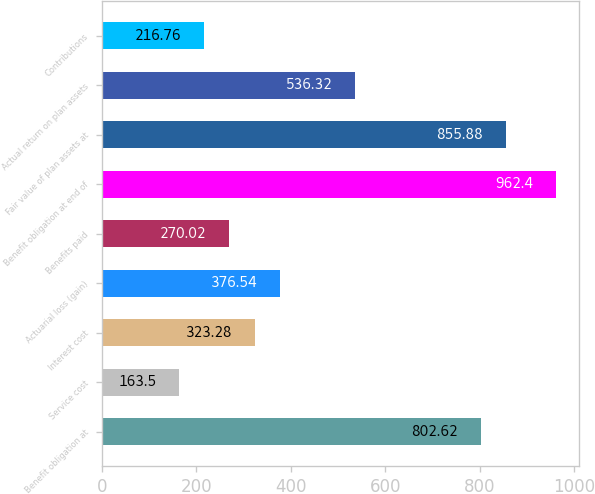Convert chart. <chart><loc_0><loc_0><loc_500><loc_500><bar_chart><fcel>Benefit obligation at<fcel>Service cost<fcel>Interest cost<fcel>Actuarial loss (gain)<fcel>Benefits paid<fcel>Benefit obligation at end of<fcel>Fair value of plan assets at<fcel>Actual return on plan assets<fcel>Contributions<nl><fcel>802.62<fcel>163.5<fcel>323.28<fcel>376.54<fcel>270.02<fcel>962.4<fcel>855.88<fcel>536.32<fcel>216.76<nl></chart> 